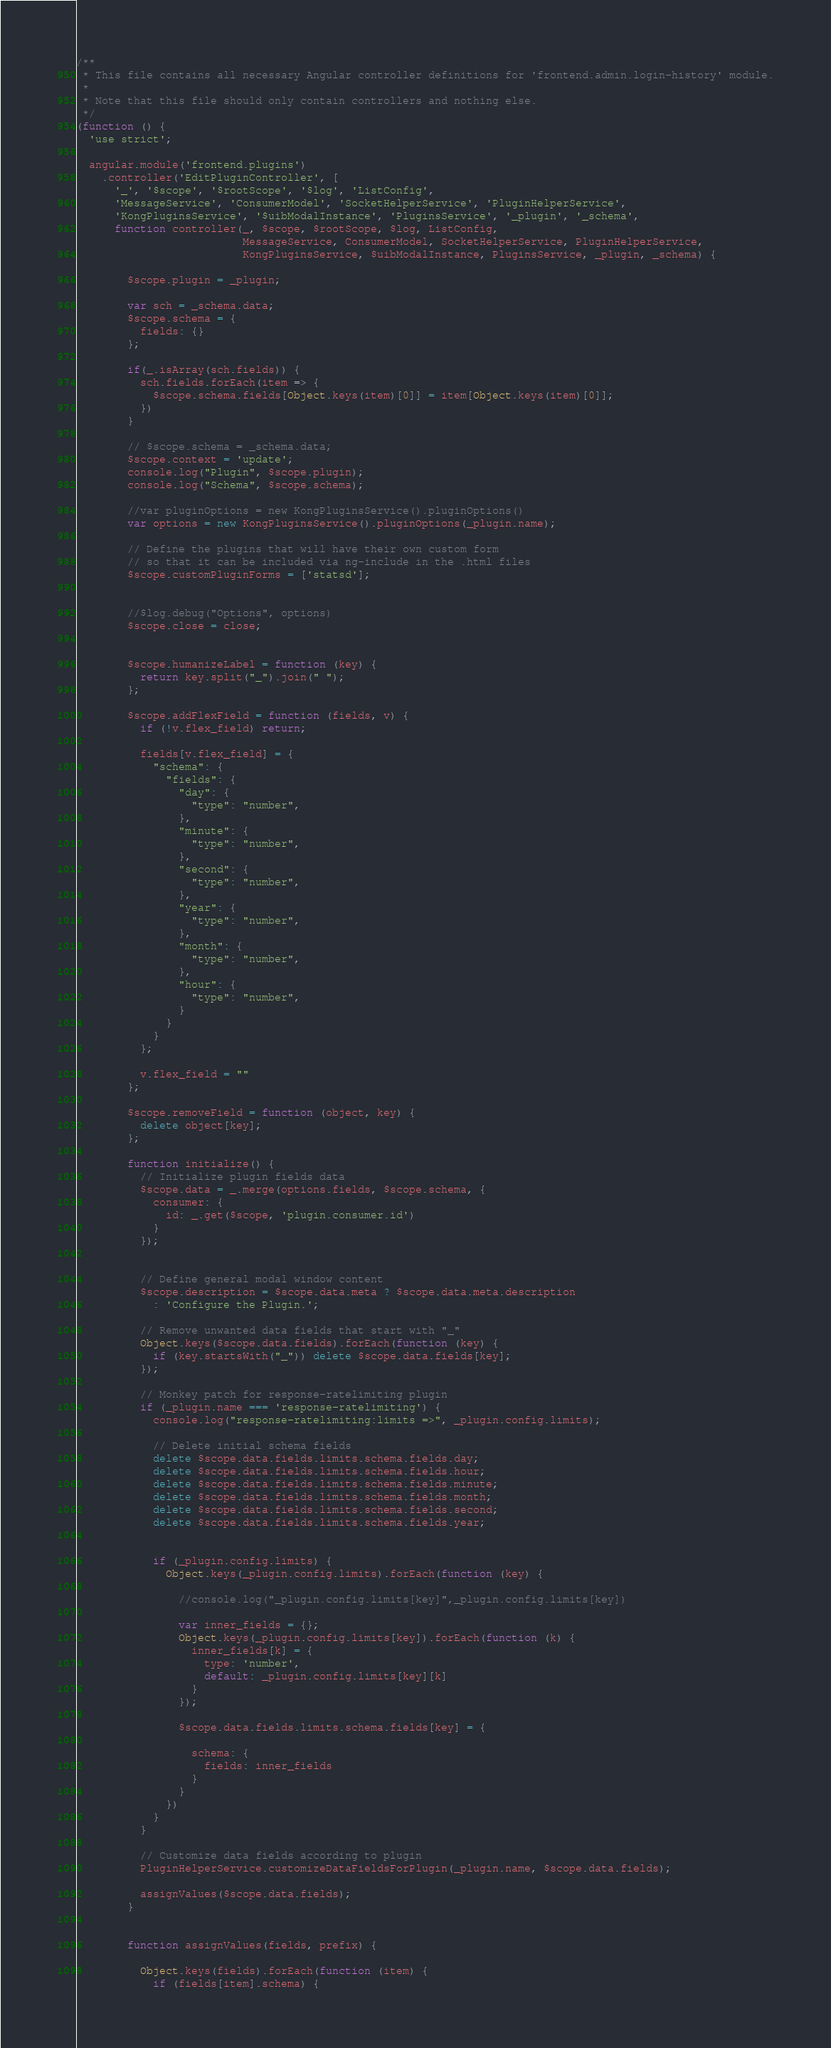<code> <loc_0><loc_0><loc_500><loc_500><_JavaScript_>/**
 * This file contains all necessary Angular controller definitions for 'frontend.admin.login-history' module.
 *
 * Note that this file should only contain controllers and nothing else.
 */
(function () {
  'use strict';

  angular.module('frontend.plugins')
    .controller('EditPluginController', [
      '_', '$scope', '$rootScope', '$log', 'ListConfig',
      'MessageService', 'ConsumerModel', 'SocketHelperService', 'PluginHelperService',
      'KongPluginsService', '$uibModalInstance', 'PluginsService', '_plugin', '_schema',
      function controller(_, $scope, $rootScope, $log, ListConfig,
                          MessageService, ConsumerModel, SocketHelperService, PluginHelperService,
                          KongPluginsService, $uibModalInstance, PluginsService, _plugin, _schema) {

        $scope.plugin = _plugin;

        var sch = _schema.data;
        $scope.schema = {
          fields: {}
        };

        if(_.isArray(sch.fields)) {
          sch.fields.forEach(item => {
            $scope.schema.fields[Object.keys(item)[0]] = item[Object.keys(item)[0]];
          })
        }

        // $scope.schema = _schema.data;
        $scope.context = 'update';
        console.log("Plugin", $scope.plugin);
        console.log("Schema", $scope.schema);

        //var pluginOptions = new KongPluginsService().pluginOptions()
        var options = new KongPluginsService().pluginOptions(_plugin.name);

        // Define the plugins that will have their own custom form
        // so that it can be included via ng-include in the .html files
        $scope.customPluginForms = ['statsd'];


        //$log.debug("Options", options)
        $scope.close = close;


        $scope.humanizeLabel = function (key) {
          return key.split("_").join(" ");
        };

        $scope.addFlexField = function (fields, v) {
          if (!v.flex_field) return;

          fields[v.flex_field] = {
            "schema": {
              "fields": {
                "day": {
                  "type": "number",
                },
                "minute": {
                  "type": "number",
                },
                "second": {
                  "type": "number",
                },
                "year": {
                  "type": "number",
                },
                "month": {
                  "type": "number",
                },
                "hour": {
                  "type": "number",
                }
              }
            }
          };

          v.flex_field = ""
        };

        $scope.removeField = function (object, key) {
          delete object[key];
        };

        function initialize() {
          // Initialize plugin fields data
          $scope.data = _.merge(options.fields, $scope.schema, {
            consumer: {
              id: _.get($scope, 'plugin.consumer.id')
            }
          });


          // Define general modal window content
          $scope.description = $scope.data.meta ? $scope.data.meta.description
            : 'Configure the Plugin.';

          // Remove unwanted data fields that start with "_"
          Object.keys($scope.data.fields).forEach(function (key) {
            if (key.startsWith("_")) delete $scope.data.fields[key];
          });

          // Monkey patch for response-ratelimiting plugin
          if (_plugin.name === 'response-ratelimiting') {
            console.log("response-ratelimiting:limits =>", _plugin.config.limits);

            // Delete initial schema fields
            delete $scope.data.fields.limits.schema.fields.day;
            delete $scope.data.fields.limits.schema.fields.hour;
            delete $scope.data.fields.limits.schema.fields.minute;
            delete $scope.data.fields.limits.schema.fields.month;
            delete $scope.data.fields.limits.schema.fields.second;
            delete $scope.data.fields.limits.schema.fields.year;


            if (_plugin.config.limits) {
              Object.keys(_plugin.config.limits).forEach(function (key) {

                //console.log("_plugin.config.limits[key]",_plugin.config.limits[key])

                var inner_fields = {};
                Object.keys(_plugin.config.limits[key]).forEach(function (k) {
                  inner_fields[k] = {
                    type: 'number',
                    default: _plugin.config.limits[key][k]
                  }
                });

                $scope.data.fields.limits.schema.fields[key] = {

                  schema: {
                    fields: inner_fields
                  }
                }
              })
            }
          }

          // Customize data fields according to plugin
          PluginHelperService.customizeDataFieldsForPlugin(_plugin.name, $scope.data.fields);

          assignValues($scope.data.fields);
        }


        function assignValues(fields, prefix) {

          Object.keys(fields).forEach(function (item) {
            if (fields[item].schema) {</code> 